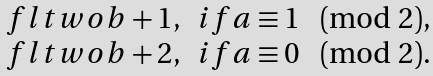<formula> <loc_0><loc_0><loc_500><loc_500>\begin{array} { c l } \ f l t w o { b } + 1 , & i f a \equiv 1 \pmod { 2 } , \\ \ f l t w o { b } + 2 , & i f a \equiv 0 \pmod { 2 } . \end{array}</formula> 